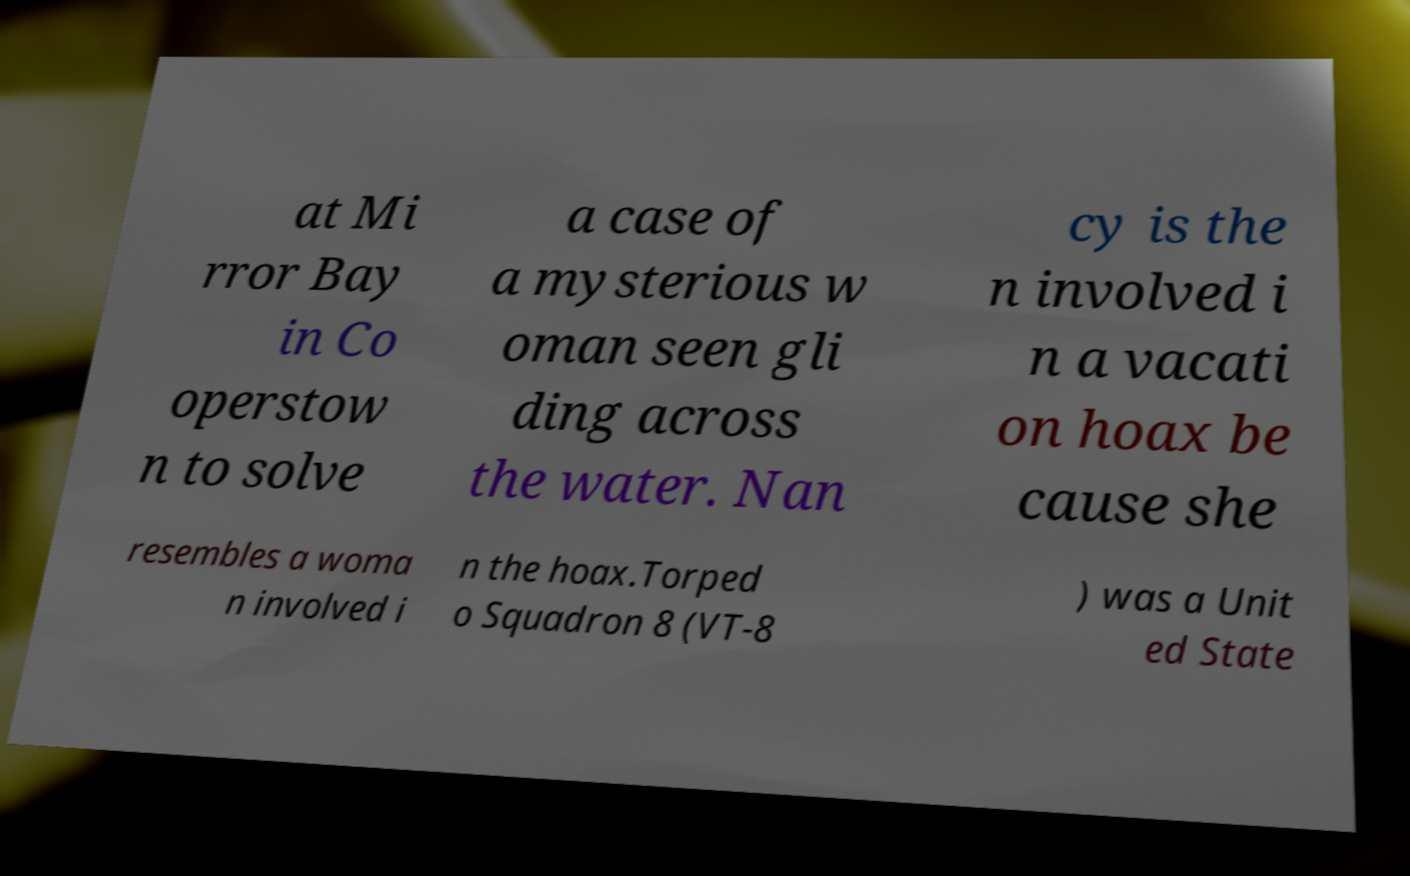Please read and relay the text visible in this image. What does it say? at Mi rror Bay in Co operstow n to solve a case of a mysterious w oman seen gli ding across the water. Nan cy is the n involved i n a vacati on hoax be cause she resembles a woma n involved i n the hoax.Torped o Squadron 8 (VT-8 ) was a Unit ed State 